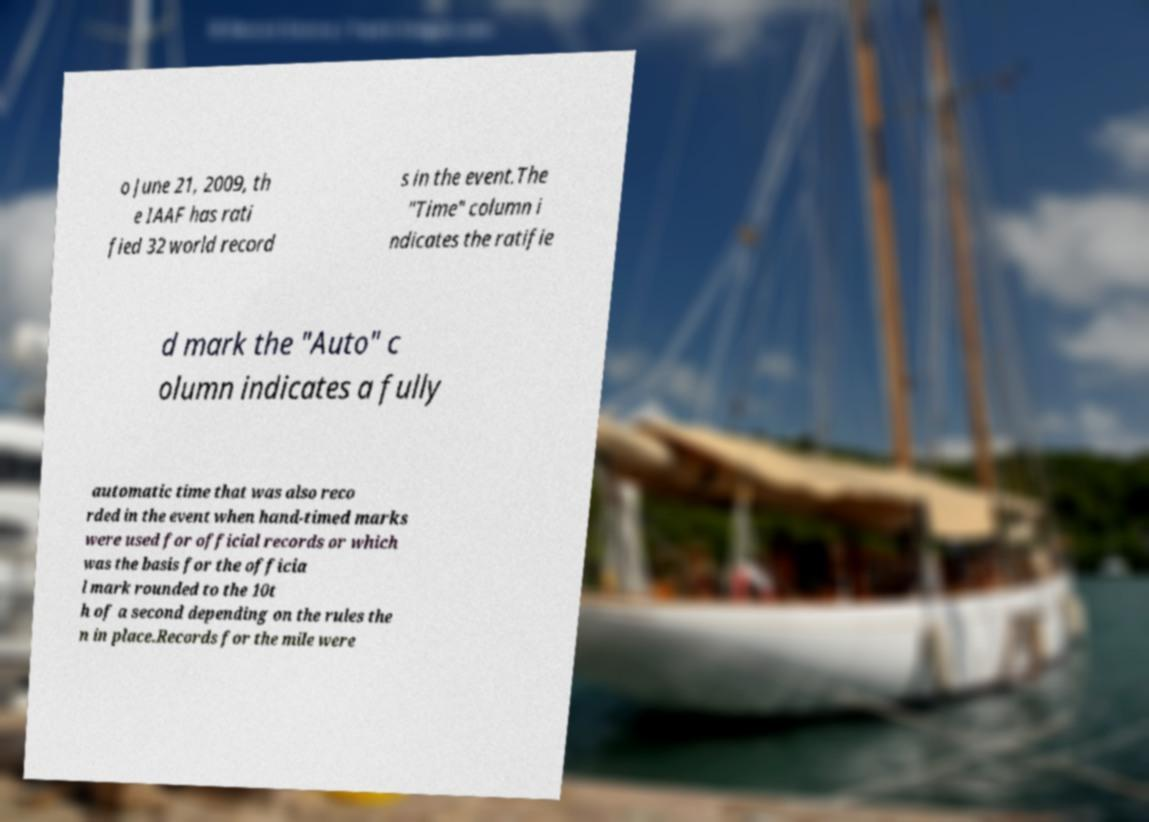For documentation purposes, I need the text within this image transcribed. Could you provide that? o June 21, 2009, th e IAAF has rati fied 32 world record s in the event.The "Time" column i ndicates the ratifie d mark the "Auto" c olumn indicates a fully automatic time that was also reco rded in the event when hand-timed marks were used for official records or which was the basis for the officia l mark rounded to the 10t h of a second depending on the rules the n in place.Records for the mile were 